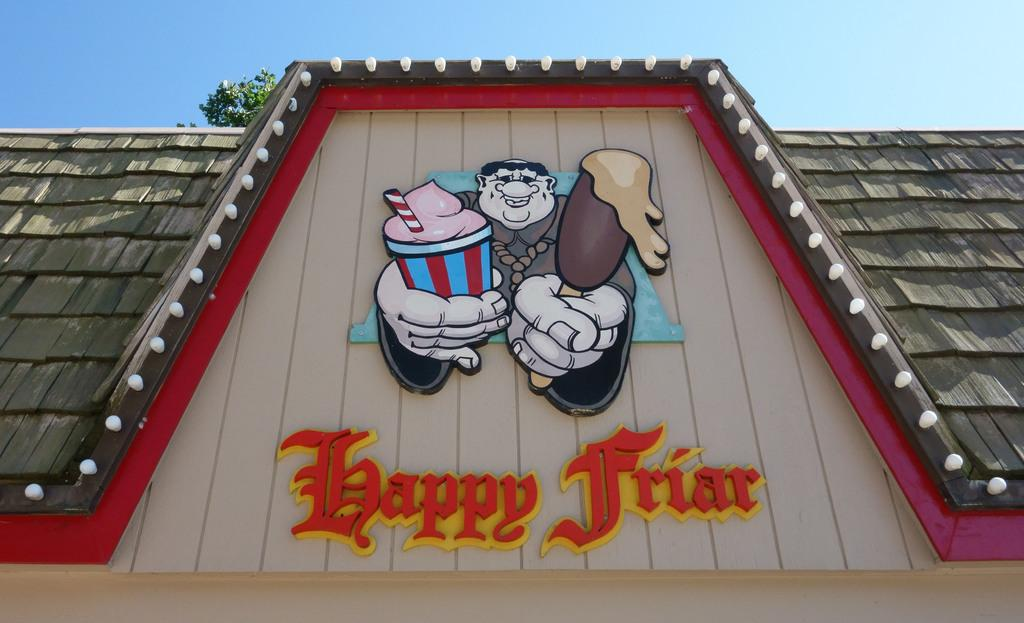What type of location is depicted in the image? The image shows a rooftop. Is there any text or label on the rooftop? Yes, there is a sticker with a name on the rooftop. What other natural element is present in the image? There is a tree in the image. What can be seen in the distance in the image? The sky is visible in the background of the image. What type of lead is being used by the servant in the image? There is no servant or lead present in the image; it features a rooftop with a sticker and a tree. Is the person driving a car in the image? There is no person or car in the image; it shows a rooftop with a sticker, a tree, and the sky in the background. 